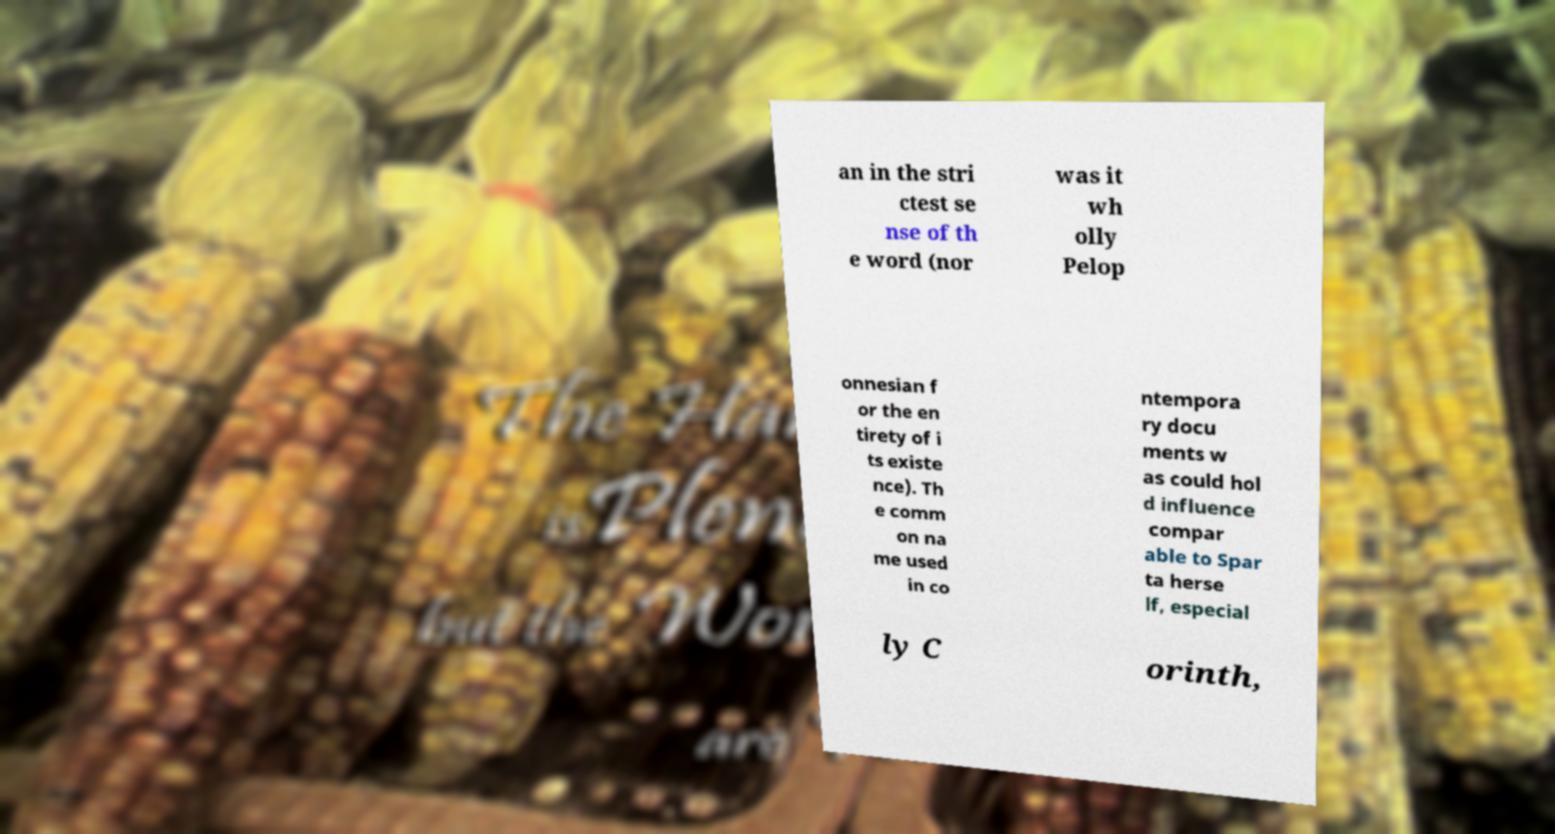Could you extract and type out the text from this image? an in the stri ctest se nse of th e word (nor was it wh olly Pelop onnesian f or the en tirety of i ts existe nce). Th e comm on na me used in co ntempora ry docu ments w as could hol d influence compar able to Spar ta herse lf, especial ly C orinth, 